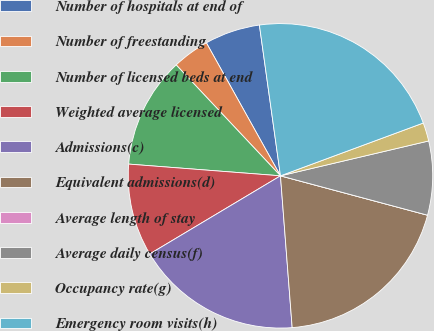<chart> <loc_0><loc_0><loc_500><loc_500><pie_chart><fcel>Number of hospitals at end of<fcel>Number of freestanding<fcel>Number of licensed beds at end<fcel>Weighted average licensed<fcel>Admissions(c)<fcel>Equivalent admissions(d)<fcel>Average length of stay<fcel>Average daily census(f)<fcel>Occupancy rate(g)<fcel>Emergency room visits(h)<nl><fcel>5.88%<fcel>3.92%<fcel>11.76%<fcel>9.8%<fcel>17.65%<fcel>19.61%<fcel>0.0%<fcel>7.84%<fcel>1.96%<fcel>21.57%<nl></chart> 